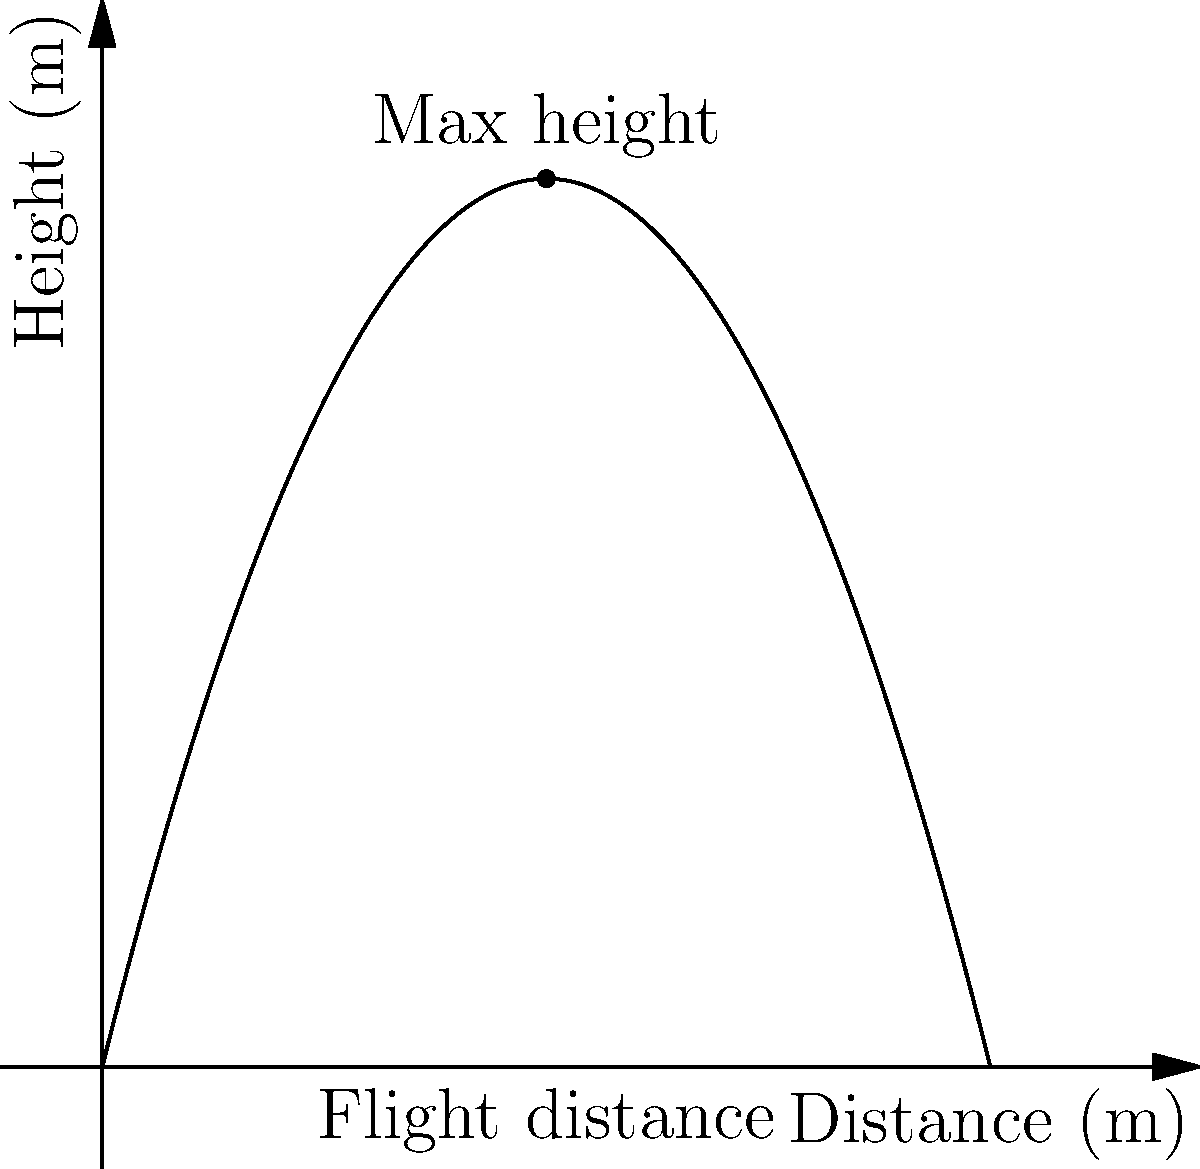In your latest MMA training session, you're practicing a flying kick inspired by Derrick Lewis's explosive moves. The path of your kick can be modeled by the quadratic function $h(x) = -0.5x^2 + 4x$, where $h$ is the height in meters and $x$ is the horizontal distance in meters. What is the maximum height reached during your kick, and at what horizontal distance does this occur? To find the maximum height of the parabolic arc and its corresponding horizontal distance, we need to follow these steps:

1) The general form of a quadratic function is $f(x) = ax^2 + bx + c$. In this case, we have $h(x) = -0.5x^2 + 4x$, so $a = -0.5$, $b = 4$, and $c = 0$.

2) For a quadratic function, the x-coordinate of the vertex (which gives us the horizontal distance at maximum height) is given by the formula: $x = -\frac{b}{2a}$

3) Let's calculate this:
   $x = -\frac{4}{2(-0.5)} = -\frac{4}{-1} = 4$ meters

4) To find the maximum height, we need to plug this x-value back into our original function:
   $h(4) = -0.5(4)^2 + 4(4)$
   $= -0.5(16) + 16$
   $= -8 + 16$
   $= 8$ meters

Therefore, the maximum height of 8 meters is reached when the horizontal distance is 4 meters.
Answer: Maximum height: 8 meters at 4 meters horizontal distance 